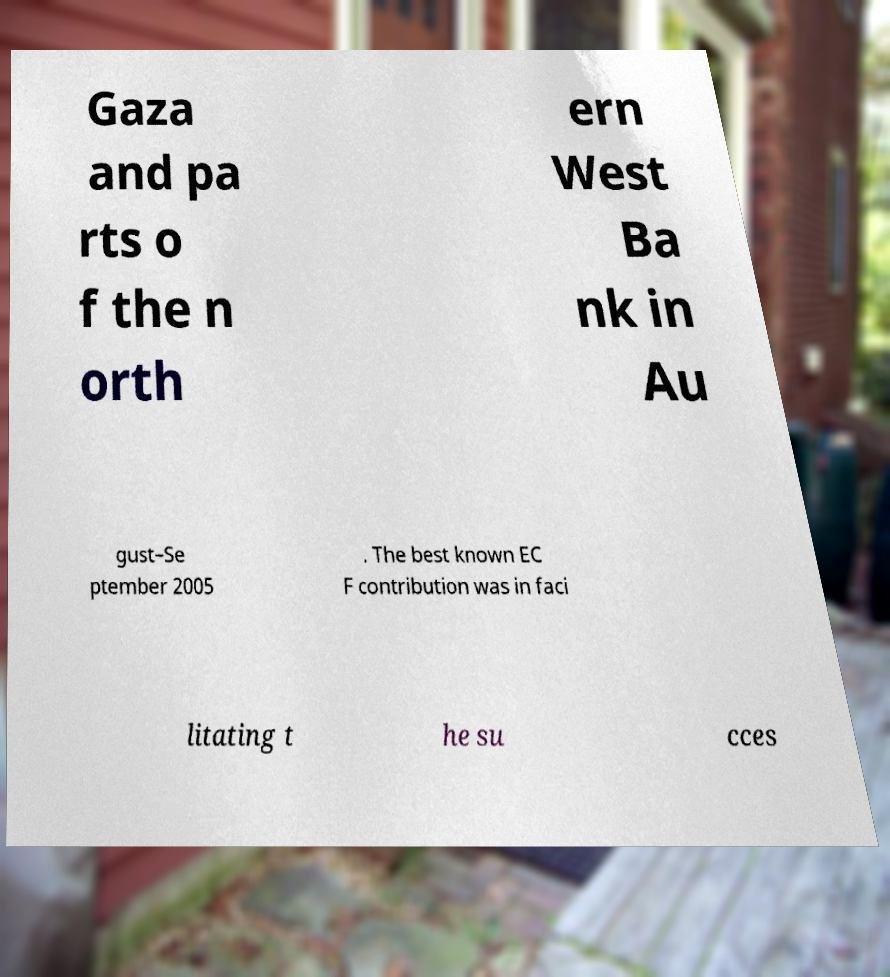Can you read and provide the text displayed in the image?This photo seems to have some interesting text. Can you extract and type it out for me? Gaza and pa rts o f the n orth ern West Ba nk in Au gust–Se ptember 2005 . The best known EC F contribution was in faci litating t he su cces 